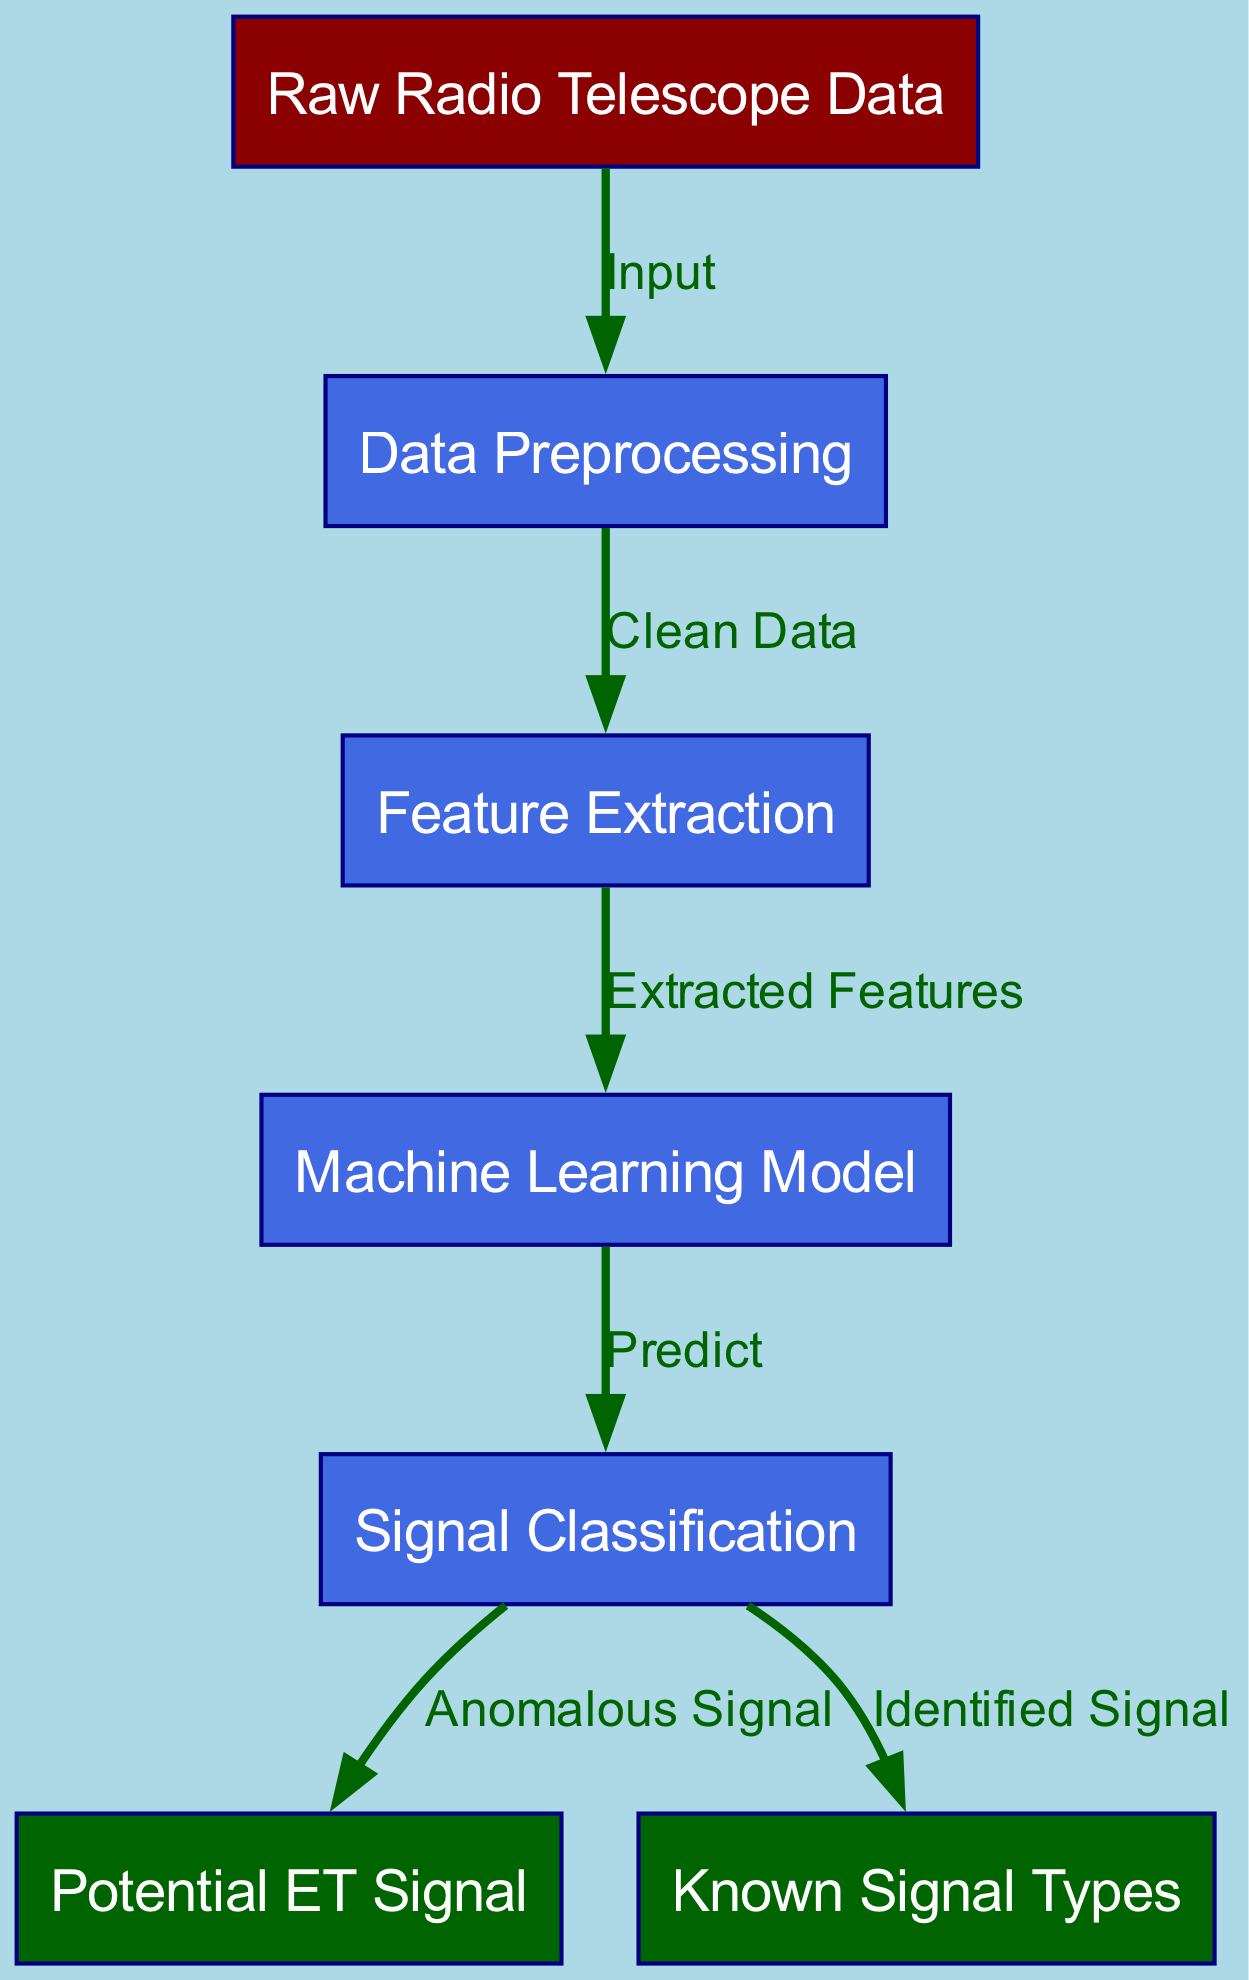what is the first node in the flowchart? The first node is identified from the diagram as "Raw Radio Telescope Data". This node is the starting point of the process shown in the flowchart.
Answer: Raw Radio Telescope Data how many nodes are in the diagram? By counting the nodes provided in the diagram data, there are a total of seven nodes.
Answer: 7 what type of signal is classified as "Anomalous Signal"? "Anomalous Signal" is the output from the "Signal Classification" step which indicates a potential extraterrestrial signal after predictions from the machine learning model.
Answer: Potential ET Signal which node connects “Data Preprocessing” and “Feature Extraction”? The edge that connects these two nodes is labeled "Clean Data", indicating a deliberate step linking data preprocessing and the extraction of features.
Answer: Clean Data what output can be generated from the "Machine Learning Model"? The "Machine Learning Model" can generate two outputs: "Anomalous Signal" and "Known Signal Types", indicating either a potential extraterrestrial signal or a classified known signal type.
Answer: Anomalous Signal, Known Signal Types how many edges are there in the diagram? A count of the edges shows that there are six connecting lines between the nodes, indicating the flow of the process.
Answer: 6 which node represents the end of the flowchart? The end of the flowchart is represented by the node "Potential ET Signal", indicating the ultimate result of the signal classification process.
Answer: Potential ET Signal what step follows after “Feature Extraction”? The step that follows after "Feature Extraction" is the "Machine Learning Model", where features are input for analysis using machine learning techniques.
Answer: Machine Learning Model what is the link between “Signal Classification” and “Known Signal Types”? The link between these two nodes is indicated as "Identified Signal", which means that the classification process leads to recognizing known signal types.
Answer: Identified Signal 